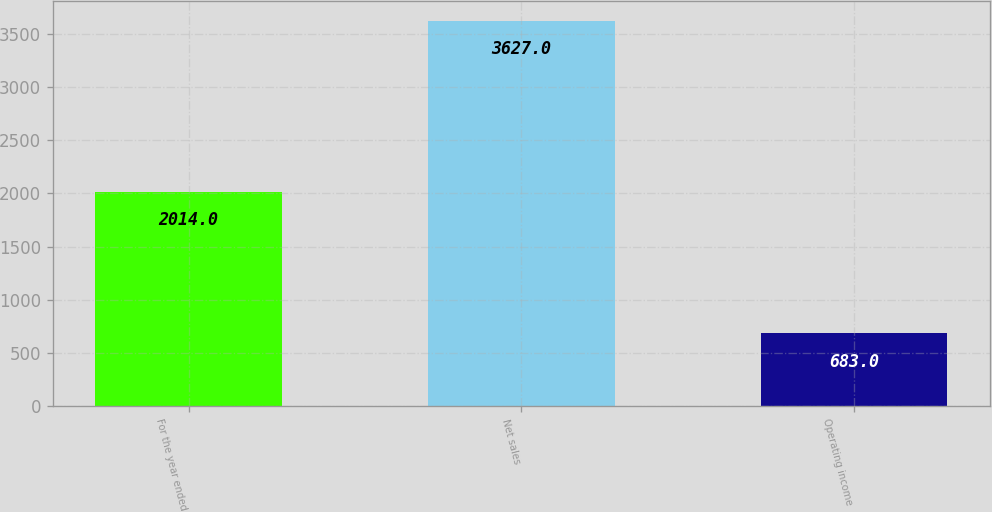Convert chart. <chart><loc_0><loc_0><loc_500><loc_500><bar_chart><fcel>For the year ended<fcel>Net sales<fcel>Operating income<nl><fcel>2014<fcel>3627<fcel>683<nl></chart> 